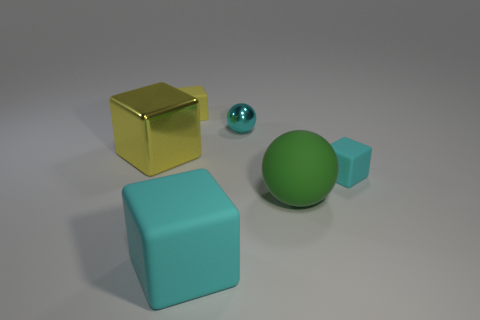How many other small spheres have the same color as the tiny shiny sphere?
Your answer should be very brief. 0. Do the large ball that is in front of the small yellow rubber cube and the tiny yellow thing have the same material?
Your answer should be compact. Yes. What number of big cyan objects are made of the same material as the large cyan block?
Offer a terse response. 0. Is the number of cyan spheres in front of the tiny sphere greater than the number of small blue matte things?
Provide a short and direct response. No. Is there a brown metal object of the same shape as the big yellow object?
Offer a terse response. No. How many objects are either big metallic things or big rubber objects?
Your answer should be compact. 3. What number of cyan things are in front of the big green matte sphere that is to the right of the cyan thing to the left of the cyan ball?
Keep it short and to the point. 1. There is a large cyan thing that is the same shape as the tiny yellow thing; what is its material?
Your answer should be compact. Rubber. There is a object that is in front of the tiny cyan rubber cube and to the right of the small shiny thing; what is it made of?
Your answer should be compact. Rubber. Are there fewer cyan rubber blocks that are behind the big matte cube than matte things that are behind the big sphere?
Offer a terse response. Yes. 